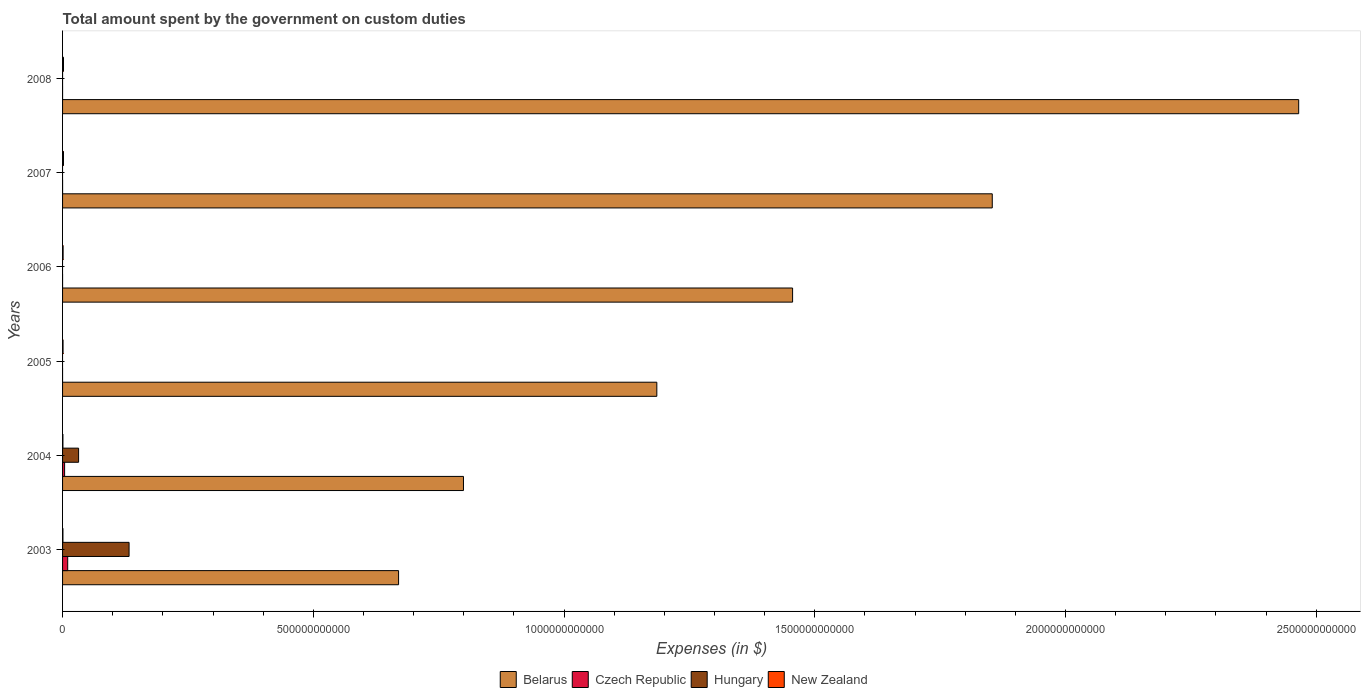Are the number of bars on each tick of the Y-axis equal?
Your response must be concise. No. How many bars are there on the 3rd tick from the top?
Provide a succinct answer. 3. How many bars are there on the 3rd tick from the bottom?
Offer a terse response. 2. What is the label of the 2nd group of bars from the top?
Ensure brevity in your answer.  2007. What is the amount spent on custom duties by the government in Belarus in 2006?
Keep it short and to the point. 1.46e+12. Across all years, what is the maximum amount spent on custom duties by the government in Belarus?
Provide a short and direct response. 2.47e+12. Across all years, what is the minimum amount spent on custom duties by the government in Hungary?
Provide a succinct answer. 0. What is the total amount spent on custom duties by the government in Czech Republic in the graph?
Offer a terse response. 1.44e+1. What is the difference between the amount spent on custom duties by the government in Belarus in 2005 and that in 2008?
Offer a terse response. -1.28e+12. What is the difference between the amount spent on custom duties by the government in Czech Republic in 2006 and the amount spent on custom duties by the government in Belarus in 2005?
Provide a succinct answer. -1.19e+12. What is the average amount spent on custom duties by the government in Czech Republic per year?
Your response must be concise. 2.40e+09. In the year 2008, what is the difference between the amount spent on custom duties by the government in New Zealand and amount spent on custom duties by the government in Belarus?
Offer a terse response. -2.46e+12. What is the ratio of the amount spent on custom duties by the government in New Zealand in 2003 to that in 2005?
Make the answer very short. 0.79. Is the difference between the amount spent on custom duties by the government in New Zealand in 2003 and 2007 greater than the difference between the amount spent on custom duties by the government in Belarus in 2003 and 2007?
Your answer should be very brief. Yes. What is the difference between the highest and the second highest amount spent on custom duties by the government in New Zealand?
Provide a short and direct response. 3.32e+07. What is the difference between the highest and the lowest amount spent on custom duties by the government in Czech Republic?
Give a very brief answer. 1.03e+1. How many years are there in the graph?
Offer a very short reply. 6. What is the difference between two consecutive major ticks on the X-axis?
Provide a succinct answer. 5.00e+11. Does the graph contain any zero values?
Make the answer very short. Yes. Does the graph contain grids?
Ensure brevity in your answer.  No. What is the title of the graph?
Ensure brevity in your answer.  Total amount spent by the government on custom duties. What is the label or title of the X-axis?
Keep it short and to the point. Expenses (in $). What is the Expenses (in $) in Belarus in 2003?
Make the answer very short. 6.70e+11. What is the Expenses (in $) of Czech Republic in 2003?
Make the answer very short. 1.03e+1. What is the Expenses (in $) of Hungary in 2003?
Keep it short and to the point. 1.33e+11. What is the Expenses (in $) of New Zealand in 2003?
Make the answer very short. 7.50e+08. What is the Expenses (in $) of Belarus in 2004?
Keep it short and to the point. 8.00e+11. What is the Expenses (in $) of Czech Republic in 2004?
Your answer should be very brief. 4.09e+09. What is the Expenses (in $) of Hungary in 2004?
Keep it short and to the point. 3.20e+1. What is the Expenses (in $) in New Zealand in 2004?
Your response must be concise. 7.20e+08. What is the Expenses (in $) of Belarus in 2005?
Provide a short and direct response. 1.19e+12. What is the Expenses (in $) in Czech Republic in 2005?
Keep it short and to the point. 0. What is the Expenses (in $) in Hungary in 2005?
Provide a short and direct response. 0. What is the Expenses (in $) of New Zealand in 2005?
Your answer should be very brief. 9.47e+08. What is the Expenses (in $) in Belarus in 2006?
Your answer should be compact. 1.46e+12. What is the Expenses (in $) in New Zealand in 2006?
Make the answer very short. 1.08e+09. What is the Expenses (in $) of Belarus in 2007?
Provide a short and direct response. 1.85e+12. What is the Expenses (in $) of Czech Republic in 2007?
Your answer should be very brief. 2.40e+07. What is the Expenses (in $) in New Zealand in 2007?
Make the answer very short. 1.84e+09. What is the Expenses (in $) in Belarus in 2008?
Offer a terse response. 2.47e+12. What is the Expenses (in $) in Hungary in 2008?
Ensure brevity in your answer.  0. What is the Expenses (in $) in New Zealand in 2008?
Provide a succinct answer. 1.87e+09. Across all years, what is the maximum Expenses (in $) in Belarus?
Provide a short and direct response. 2.47e+12. Across all years, what is the maximum Expenses (in $) of Czech Republic?
Provide a short and direct response. 1.03e+1. Across all years, what is the maximum Expenses (in $) of Hungary?
Offer a very short reply. 1.33e+11. Across all years, what is the maximum Expenses (in $) of New Zealand?
Offer a terse response. 1.87e+09. Across all years, what is the minimum Expenses (in $) of Belarus?
Provide a succinct answer. 6.70e+11. Across all years, what is the minimum Expenses (in $) in Czech Republic?
Your answer should be very brief. 0. Across all years, what is the minimum Expenses (in $) of New Zealand?
Make the answer very short. 7.20e+08. What is the total Expenses (in $) of Belarus in the graph?
Keep it short and to the point. 8.43e+12. What is the total Expenses (in $) of Czech Republic in the graph?
Your response must be concise. 1.44e+1. What is the total Expenses (in $) in Hungary in the graph?
Keep it short and to the point. 1.65e+11. What is the total Expenses (in $) in New Zealand in the graph?
Your answer should be compact. 7.20e+09. What is the difference between the Expenses (in $) in Belarus in 2003 and that in 2004?
Offer a very short reply. -1.29e+11. What is the difference between the Expenses (in $) in Czech Republic in 2003 and that in 2004?
Make the answer very short. 6.17e+09. What is the difference between the Expenses (in $) of Hungary in 2003 and that in 2004?
Provide a succinct answer. 1.01e+11. What is the difference between the Expenses (in $) in New Zealand in 2003 and that in 2004?
Ensure brevity in your answer.  2.95e+07. What is the difference between the Expenses (in $) in Belarus in 2003 and that in 2005?
Provide a succinct answer. -5.15e+11. What is the difference between the Expenses (in $) in New Zealand in 2003 and that in 2005?
Make the answer very short. -1.97e+08. What is the difference between the Expenses (in $) of Belarus in 2003 and that in 2006?
Your answer should be compact. -7.86e+11. What is the difference between the Expenses (in $) of Czech Republic in 2003 and that in 2006?
Provide a short and direct response. 1.02e+1. What is the difference between the Expenses (in $) in New Zealand in 2003 and that in 2006?
Your answer should be very brief. -3.33e+08. What is the difference between the Expenses (in $) in Belarus in 2003 and that in 2007?
Your response must be concise. -1.18e+12. What is the difference between the Expenses (in $) of Czech Republic in 2003 and that in 2007?
Make the answer very short. 1.02e+1. What is the difference between the Expenses (in $) in New Zealand in 2003 and that in 2007?
Give a very brief answer. -1.09e+09. What is the difference between the Expenses (in $) of Belarus in 2003 and that in 2008?
Ensure brevity in your answer.  -1.80e+12. What is the difference between the Expenses (in $) of Czech Republic in 2003 and that in 2008?
Provide a short and direct response. 1.02e+1. What is the difference between the Expenses (in $) of New Zealand in 2003 and that in 2008?
Ensure brevity in your answer.  -1.12e+09. What is the difference between the Expenses (in $) of Belarus in 2004 and that in 2005?
Your answer should be compact. -3.86e+11. What is the difference between the Expenses (in $) of New Zealand in 2004 and that in 2005?
Your response must be concise. -2.26e+08. What is the difference between the Expenses (in $) of Belarus in 2004 and that in 2006?
Keep it short and to the point. -6.56e+11. What is the difference between the Expenses (in $) of Czech Republic in 2004 and that in 2006?
Provide a succinct answer. 4.08e+09. What is the difference between the Expenses (in $) of New Zealand in 2004 and that in 2006?
Give a very brief answer. -3.63e+08. What is the difference between the Expenses (in $) in Belarus in 2004 and that in 2007?
Your answer should be compact. -1.05e+12. What is the difference between the Expenses (in $) in Czech Republic in 2004 and that in 2007?
Ensure brevity in your answer.  4.06e+09. What is the difference between the Expenses (in $) of New Zealand in 2004 and that in 2007?
Give a very brief answer. -1.12e+09. What is the difference between the Expenses (in $) in Belarus in 2004 and that in 2008?
Provide a succinct answer. -1.67e+12. What is the difference between the Expenses (in $) of Czech Republic in 2004 and that in 2008?
Offer a very short reply. 4.08e+09. What is the difference between the Expenses (in $) of New Zealand in 2004 and that in 2008?
Your answer should be compact. -1.15e+09. What is the difference between the Expenses (in $) of Belarus in 2005 and that in 2006?
Provide a succinct answer. -2.71e+11. What is the difference between the Expenses (in $) of New Zealand in 2005 and that in 2006?
Offer a terse response. -1.36e+08. What is the difference between the Expenses (in $) of Belarus in 2005 and that in 2007?
Ensure brevity in your answer.  -6.69e+11. What is the difference between the Expenses (in $) of New Zealand in 2005 and that in 2007?
Your answer should be compact. -8.89e+08. What is the difference between the Expenses (in $) of Belarus in 2005 and that in 2008?
Your response must be concise. -1.28e+12. What is the difference between the Expenses (in $) of New Zealand in 2005 and that in 2008?
Your answer should be compact. -9.22e+08. What is the difference between the Expenses (in $) in Belarus in 2006 and that in 2007?
Keep it short and to the point. -3.98e+11. What is the difference between the Expenses (in $) in Czech Republic in 2006 and that in 2007?
Provide a succinct answer. -1.80e+07. What is the difference between the Expenses (in $) in New Zealand in 2006 and that in 2007?
Provide a succinct answer. -7.53e+08. What is the difference between the Expenses (in $) of Belarus in 2006 and that in 2008?
Offer a terse response. -1.01e+12. What is the difference between the Expenses (in $) in New Zealand in 2006 and that in 2008?
Your answer should be very brief. -7.86e+08. What is the difference between the Expenses (in $) in Belarus in 2007 and that in 2008?
Provide a succinct answer. -6.11e+11. What is the difference between the Expenses (in $) in Czech Republic in 2007 and that in 2008?
Your answer should be very brief. 1.60e+07. What is the difference between the Expenses (in $) of New Zealand in 2007 and that in 2008?
Provide a succinct answer. -3.32e+07. What is the difference between the Expenses (in $) in Belarus in 2003 and the Expenses (in $) in Czech Republic in 2004?
Provide a short and direct response. 6.66e+11. What is the difference between the Expenses (in $) of Belarus in 2003 and the Expenses (in $) of Hungary in 2004?
Keep it short and to the point. 6.38e+11. What is the difference between the Expenses (in $) in Belarus in 2003 and the Expenses (in $) in New Zealand in 2004?
Offer a very short reply. 6.69e+11. What is the difference between the Expenses (in $) of Czech Republic in 2003 and the Expenses (in $) of Hungary in 2004?
Your answer should be compact. -2.17e+1. What is the difference between the Expenses (in $) of Czech Republic in 2003 and the Expenses (in $) of New Zealand in 2004?
Your answer should be compact. 9.53e+09. What is the difference between the Expenses (in $) of Hungary in 2003 and the Expenses (in $) of New Zealand in 2004?
Ensure brevity in your answer.  1.32e+11. What is the difference between the Expenses (in $) of Belarus in 2003 and the Expenses (in $) of New Zealand in 2005?
Provide a short and direct response. 6.69e+11. What is the difference between the Expenses (in $) in Czech Republic in 2003 and the Expenses (in $) in New Zealand in 2005?
Your response must be concise. 9.31e+09. What is the difference between the Expenses (in $) in Hungary in 2003 and the Expenses (in $) in New Zealand in 2005?
Provide a short and direct response. 1.32e+11. What is the difference between the Expenses (in $) in Belarus in 2003 and the Expenses (in $) in Czech Republic in 2006?
Provide a succinct answer. 6.70e+11. What is the difference between the Expenses (in $) of Belarus in 2003 and the Expenses (in $) of New Zealand in 2006?
Provide a succinct answer. 6.69e+11. What is the difference between the Expenses (in $) of Czech Republic in 2003 and the Expenses (in $) of New Zealand in 2006?
Give a very brief answer. 9.17e+09. What is the difference between the Expenses (in $) in Hungary in 2003 and the Expenses (in $) in New Zealand in 2006?
Provide a short and direct response. 1.32e+11. What is the difference between the Expenses (in $) of Belarus in 2003 and the Expenses (in $) of Czech Republic in 2007?
Ensure brevity in your answer.  6.70e+11. What is the difference between the Expenses (in $) in Belarus in 2003 and the Expenses (in $) in New Zealand in 2007?
Your response must be concise. 6.68e+11. What is the difference between the Expenses (in $) of Czech Republic in 2003 and the Expenses (in $) of New Zealand in 2007?
Offer a terse response. 8.42e+09. What is the difference between the Expenses (in $) of Hungary in 2003 and the Expenses (in $) of New Zealand in 2007?
Provide a short and direct response. 1.31e+11. What is the difference between the Expenses (in $) in Belarus in 2003 and the Expenses (in $) in Czech Republic in 2008?
Offer a very short reply. 6.70e+11. What is the difference between the Expenses (in $) in Belarus in 2003 and the Expenses (in $) in New Zealand in 2008?
Ensure brevity in your answer.  6.68e+11. What is the difference between the Expenses (in $) in Czech Republic in 2003 and the Expenses (in $) in New Zealand in 2008?
Offer a very short reply. 8.38e+09. What is the difference between the Expenses (in $) of Hungary in 2003 and the Expenses (in $) of New Zealand in 2008?
Offer a terse response. 1.31e+11. What is the difference between the Expenses (in $) of Belarus in 2004 and the Expenses (in $) of New Zealand in 2005?
Offer a very short reply. 7.99e+11. What is the difference between the Expenses (in $) in Czech Republic in 2004 and the Expenses (in $) in New Zealand in 2005?
Ensure brevity in your answer.  3.14e+09. What is the difference between the Expenses (in $) of Hungary in 2004 and the Expenses (in $) of New Zealand in 2005?
Your answer should be compact. 3.10e+1. What is the difference between the Expenses (in $) in Belarus in 2004 and the Expenses (in $) in Czech Republic in 2006?
Your response must be concise. 8.00e+11. What is the difference between the Expenses (in $) of Belarus in 2004 and the Expenses (in $) of New Zealand in 2006?
Your answer should be very brief. 7.98e+11. What is the difference between the Expenses (in $) in Czech Republic in 2004 and the Expenses (in $) in New Zealand in 2006?
Your answer should be compact. 3.00e+09. What is the difference between the Expenses (in $) in Hungary in 2004 and the Expenses (in $) in New Zealand in 2006?
Keep it short and to the point. 3.09e+1. What is the difference between the Expenses (in $) of Belarus in 2004 and the Expenses (in $) of Czech Republic in 2007?
Keep it short and to the point. 8.00e+11. What is the difference between the Expenses (in $) in Belarus in 2004 and the Expenses (in $) in New Zealand in 2007?
Your response must be concise. 7.98e+11. What is the difference between the Expenses (in $) of Czech Republic in 2004 and the Expenses (in $) of New Zealand in 2007?
Provide a short and direct response. 2.25e+09. What is the difference between the Expenses (in $) of Hungary in 2004 and the Expenses (in $) of New Zealand in 2007?
Provide a succinct answer. 3.01e+1. What is the difference between the Expenses (in $) of Belarus in 2004 and the Expenses (in $) of Czech Republic in 2008?
Make the answer very short. 8.00e+11. What is the difference between the Expenses (in $) of Belarus in 2004 and the Expenses (in $) of New Zealand in 2008?
Keep it short and to the point. 7.98e+11. What is the difference between the Expenses (in $) of Czech Republic in 2004 and the Expenses (in $) of New Zealand in 2008?
Give a very brief answer. 2.22e+09. What is the difference between the Expenses (in $) in Hungary in 2004 and the Expenses (in $) in New Zealand in 2008?
Provide a short and direct response. 3.01e+1. What is the difference between the Expenses (in $) of Belarus in 2005 and the Expenses (in $) of Czech Republic in 2006?
Offer a terse response. 1.19e+12. What is the difference between the Expenses (in $) of Belarus in 2005 and the Expenses (in $) of New Zealand in 2006?
Your answer should be very brief. 1.18e+12. What is the difference between the Expenses (in $) in Belarus in 2005 and the Expenses (in $) in Czech Republic in 2007?
Your answer should be compact. 1.19e+12. What is the difference between the Expenses (in $) in Belarus in 2005 and the Expenses (in $) in New Zealand in 2007?
Offer a terse response. 1.18e+12. What is the difference between the Expenses (in $) in Belarus in 2005 and the Expenses (in $) in Czech Republic in 2008?
Offer a terse response. 1.19e+12. What is the difference between the Expenses (in $) of Belarus in 2005 and the Expenses (in $) of New Zealand in 2008?
Offer a very short reply. 1.18e+12. What is the difference between the Expenses (in $) in Belarus in 2006 and the Expenses (in $) in Czech Republic in 2007?
Offer a very short reply. 1.46e+12. What is the difference between the Expenses (in $) in Belarus in 2006 and the Expenses (in $) in New Zealand in 2007?
Provide a succinct answer. 1.45e+12. What is the difference between the Expenses (in $) in Czech Republic in 2006 and the Expenses (in $) in New Zealand in 2007?
Keep it short and to the point. -1.83e+09. What is the difference between the Expenses (in $) in Belarus in 2006 and the Expenses (in $) in Czech Republic in 2008?
Make the answer very short. 1.46e+12. What is the difference between the Expenses (in $) of Belarus in 2006 and the Expenses (in $) of New Zealand in 2008?
Give a very brief answer. 1.45e+12. What is the difference between the Expenses (in $) in Czech Republic in 2006 and the Expenses (in $) in New Zealand in 2008?
Keep it short and to the point. -1.86e+09. What is the difference between the Expenses (in $) in Belarus in 2007 and the Expenses (in $) in Czech Republic in 2008?
Ensure brevity in your answer.  1.85e+12. What is the difference between the Expenses (in $) of Belarus in 2007 and the Expenses (in $) of New Zealand in 2008?
Ensure brevity in your answer.  1.85e+12. What is the difference between the Expenses (in $) in Czech Republic in 2007 and the Expenses (in $) in New Zealand in 2008?
Ensure brevity in your answer.  -1.85e+09. What is the average Expenses (in $) in Belarus per year?
Give a very brief answer. 1.40e+12. What is the average Expenses (in $) of Czech Republic per year?
Ensure brevity in your answer.  2.40e+09. What is the average Expenses (in $) in Hungary per year?
Keep it short and to the point. 2.74e+1. What is the average Expenses (in $) in New Zealand per year?
Your answer should be very brief. 1.20e+09. In the year 2003, what is the difference between the Expenses (in $) in Belarus and Expenses (in $) in Czech Republic?
Offer a terse response. 6.60e+11. In the year 2003, what is the difference between the Expenses (in $) in Belarus and Expenses (in $) in Hungary?
Offer a very short reply. 5.37e+11. In the year 2003, what is the difference between the Expenses (in $) of Belarus and Expenses (in $) of New Zealand?
Make the answer very short. 6.69e+11. In the year 2003, what is the difference between the Expenses (in $) of Czech Republic and Expenses (in $) of Hungary?
Give a very brief answer. -1.22e+11. In the year 2003, what is the difference between the Expenses (in $) of Czech Republic and Expenses (in $) of New Zealand?
Make the answer very short. 9.50e+09. In the year 2003, what is the difference between the Expenses (in $) of Hungary and Expenses (in $) of New Zealand?
Make the answer very short. 1.32e+11. In the year 2004, what is the difference between the Expenses (in $) of Belarus and Expenses (in $) of Czech Republic?
Your answer should be very brief. 7.95e+11. In the year 2004, what is the difference between the Expenses (in $) of Belarus and Expenses (in $) of Hungary?
Your answer should be very brief. 7.68e+11. In the year 2004, what is the difference between the Expenses (in $) in Belarus and Expenses (in $) in New Zealand?
Keep it short and to the point. 7.99e+11. In the year 2004, what is the difference between the Expenses (in $) of Czech Republic and Expenses (in $) of Hungary?
Your answer should be compact. -2.79e+1. In the year 2004, what is the difference between the Expenses (in $) of Czech Republic and Expenses (in $) of New Zealand?
Provide a succinct answer. 3.37e+09. In the year 2004, what is the difference between the Expenses (in $) of Hungary and Expenses (in $) of New Zealand?
Your answer should be compact. 3.12e+1. In the year 2005, what is the difference between the Expenses (in $) of Belarus and Expenses (in $) of New Zealand?
Provide a short and direct response. 1.18e+12. In the year 2006, what is the difference between the Expenses (in $) in Belarus and Expenses (in $) in Czech Republic?
Provide a short and direct response. 1.46e+12. In the year 2006, what is the difference between the Expenses (in $) in Belarus and Expenses (in $) in New Zealand?
Provide a succinct answer. 1.45e+12. In the year 2006, what is the difference between the Expenses (in $) of Czech Republic and Expenses (in $) of New Zealand?
Keep it short and to the point. -1.08e+09. In the year 2007, what is the difference between the Expenses (in $) of Belarus and Expenses (in $) of Czech Republic?
Provide a short and direct response. 1.85e+12. In the year 2007, what is the difference between the Expenses (in $) in Belarus and Expenses (in $) in New Zealand?
Offer a very short reply. 1.85e+12. In the year 2007, what is the difference between the Expenses (in $) of Czech Republic and Expenses (in $) of New Zealand?
Make the answer very short. -1.81e+09. In the year 2008, what is the difference between the Expenses (in $) in Belarus and Expenses (in $) in Czech Republic?
Offer a very short reply. 2.47e+12. In the year 2008, what is the difference between the Expenses (in $) in Belarus and Expenses (in $) in New Zealand?
Make the answer very short. 2.46e+12. In the year 2008, what is the difference between the Expenses (in $) of Czech Republic and Expenses (in $) of New Zealand?
Ensure brevity in your answer.  -1.86e+09. What is the ratio of the Expenses (in $) of Belarus in 2003 to that in 2004?
Your answer should be compact. 0.84. What is the ratio of the Expenses (in $) in Czech Republic in 2003 to that in 2004?
Your answer should be very brief. 2.51. What is the ratio of the Expenses (in $) of Hungary in 2003 to that in 2004?
Provide a short and direct response. 4.15. What is the ratio of the Expenses (in $) of New Zealand in 2003 to that in 2004?
Your answer should be compact. 1.04. What is the ratio of the Expenses (in $) in Belarus in 2003 to that in 2005?
Your response must be concise. 0.57. What is the ratio of the Expenses (in $) in New Zealand in 2003 to that in 2005?
Ensure brevity in your answer.  0.79. What is the ratio of the Expenses (in $) of Belarus in 2003 to that in 2006?
Offer a very short reply. 0.46. What is the ratio of the Expenses (in $) in Czech Republic in 2003 to that in 2006?
Your answer should be very brief. 1708.67. What is the ratio of the Expenses (in $) of New Zealand in 2003 to that in 2006?
Provide a short and direct response. 0.69. What is the ratio of the Expenses (in $) of Belarus in 2003 to that in 2007?
Provide a succinct answer. 0.36. What is the ratio of the Expenses (in $) in Czech Republic in 2003 to that in 2007?
Offer a very short reply. 427.17. What is the ratio of the Expenses (in $) in New Zealand in 2003 to that in 2007?
Give a very brief answer. 0.41. What is the ratio of the Expenses (in $) of Belarus in 2003 to that in 2008?
Ensure brevity in your answer.  0.27. What is the ratio of the Expenses (in $) of Czech Republic in 2003 to that in 2008?
Your response must be concise. 1281.5. What is the ratio of the Expenses (in $) of New Zealand in 2003 to that in 2008?
Your answer should be very brief. 0.4. What is the ratio of the Expenses (in $) of Belarus in 2004 to that in 2005?
Give a very brief answer. 0.67. What is the ratio of the Expenses (in $) of New Zealand in 2004 to that in 2005?
Your response must be concise. 0.76. What is the ratio of the Expenses (in $) in Belarus in 2004 to that in 2006?
Give a very brief answer. 0.55. What is the ratio of the Expenses (in $) in Czech Republic in 2004 to that in 2006?
Provide a succinct answer. 681. What is the ratio of the Expenses (in $) of New Zealand in 2004 to that in 2006?
Ensure brevity in your answer.  0.67. What is the ratio of the Expenses (in $) of Belarus in 2004 to that in 2007?
Make the answer very short. 0.43. What is the ratio of the Expenses (in $) in Czech Republic in 2004 to that in 2007?
Provide a short and direct response. 170.25. What is the ratio of the Expenses (in $) in New Zealand in 2004 to that in 2007?
Provide a short and direct response. 0.39. What is the ratio of the Expenses (in $) in Belarus in 2004 to that in 2008?
Provide a succinct answer. 0.32. What is the ratio of the Expenses (in $) of Czech Republic in 2004 to that in 2008?
Provide a succinct answer. 510.75. What is the ratio of the Expenses (in $) in New Zealand in 2004 to that in 2008?
Make the answer very short. 0.39. What is the ratio of the Expenses (in $) of Belarus in 2005 to that in 2006?
Give a very brief answer. 0.81. What is the ratio of the Expenses (in $) of New Zealand in 2005 to that in 2006?
Make the answer very short. 0.87. What is the ratio of the Expenses (in $) in Belarus in 2005 to that in 2007?
Offer a very short reply. 0.64. What is the ratio of the Expenses (in $) in New Zealand in 2005 to that in 2007?
Your answer should be very brief. 0.52. What is the ratio of the Expenses (in $) of Belarus in 2005 to that in 2008?
Your answer should be very brief. 0.48. What is the ratio of the Expenses (in $) of New Zealand in 2005 to that in 2008?
Offer a terse response. 0.51. What is the ratio of the Expenses (in $) of Belarus in 2006 to that in 2007?
Your answer should be compact. 0.79. What is the ratio of the Expenses (in $) of New Zealand in 2006 to that in 2007?
Your response must be concise. 0.59. What is the ratio of the Expenses (in $) in Belarus in 2006 to that in 2008?
Your answer should be compact. 0.59. What is the ratio of the Expenses (in $) of New Zealand in 2006 to that in 2008?
Offer a very short reply. 0.58. What is the ratio of the Expenses (in $) in Belarus in 2007 to that in 2008?
Ensure brevity in your answer.  0.75. What is the ratio of the Expenses (in $) in New Zealand in 2007 to that in 2008?
Give a very brief answer. 0.98. What is the difference between the highest and the second highest Expenses (in $) in Belarus?
Give a very brief answer. 6.11e+11. What is the difference between the highest and the second highest Expenses (in $) of Czech Republic?
Make the answer very short. 6.17e+09. What is the difference between the highest and the second highest Expenses (in $) in New Zealand?
Give a very brief answer. 3.32e+07. What is the difference between the highest and the lowest Expenses (in $) in Belarus?
Make the answer very short. 1.80e+12. What is the difference between the highest and the lowest Expenses (in $) of Czech Republic?
Provide a succinct answer. 1.03e+1. What is the difference between the highest and the lowest Expenses (in $) in Hungary?
Your answer should be very brief. 1.33e+11. What is the difference between the highest and the lowest Expenses (in $) of New Zealand?
Keep it short and to the point. 1.15e+09. 